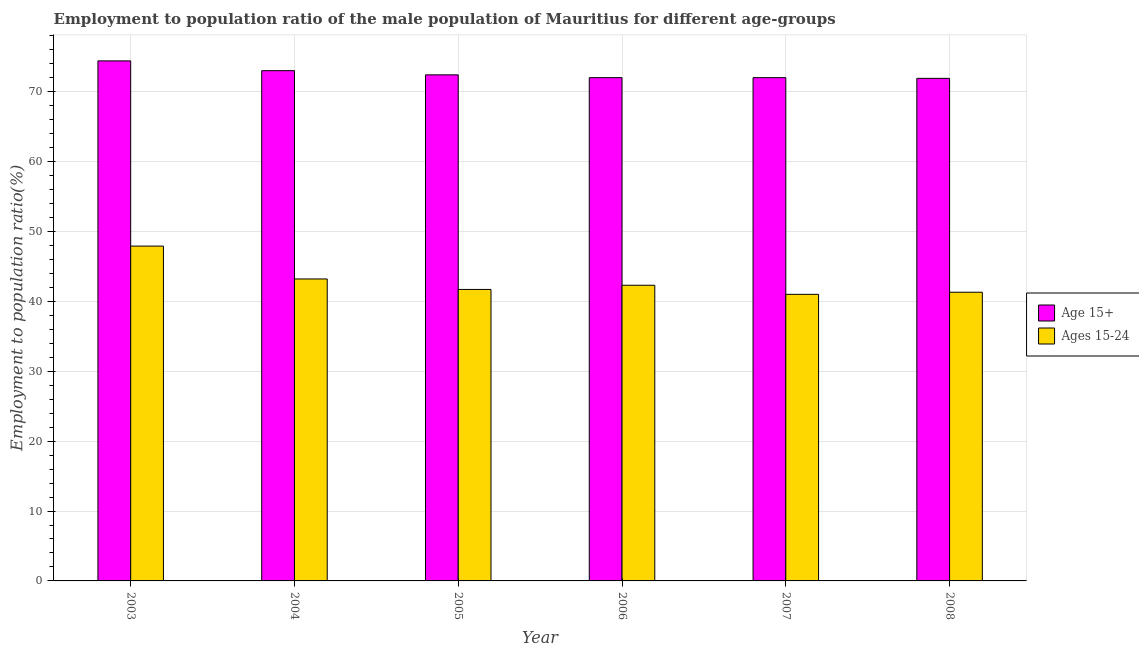How many groups of bars are there?
Ensure brevity in your answer.  6. Are the number of bars on each tick of the X-axis equal?
Give a very brief answer. Yes. How many bars are there on the 6th tick from the right?
Offer a terse response. 2. What is the employment to population ratio(age 15-24) in 2007?
Ensure brevity in your answer.  41. Across all years, what is the maximum employment to population ratio(age 15-24)?
Your response must be concise. 47.9. Across all years, what is the minimum employment to population ratio(age 15-24)?
Your answer should be compact. 41. What is the total employment to population ratio(age 15-24) in the graph?
Ensure brevity in your answer.  257.4. What is the difference between the employment to population ratio(age 15+) in 2007 and that in 2008?
Make the answer very short. 0.1. What is the difference between the employment to population ratio(age 15+) in 2005 and the employment to population ratio(age 15-24) in 2007?
Offer a terse response. 0.4. What is the average employment to population ratio(age 15-24) per year?
Offer a terse response. 42.9. In the year 2006, what is the difference between the employment to population ratio(age 15+) and employment to population ratio(age 15-24)?
Offer a terse response. 0. What is the ratio of the employment to population ratio(age 15+) in 2006 to that in 2008?
Give a very brief answer. 1. Is the difference between the employment to population ratio(age 15-24) in 2003 and 2005 greater than the difference between the employment to population ratio(age 15+) in 2003 and 2005?
Your answer should be compact. No. What is the difference between the highest and the second highest employment to population ratio(age 15+)?
Offer a very short reply. 1.4. What is the difference between the highest and the lowest employment to population ratio(age 15-24)?
Keep it short and to the point. 6.9. Is the sum of the employment to population ratio(age 15-24) in 2005 and 2007 greater than the maximum employment to population ratio(age 15+) across all years?
Make the answer very short. Yes. What does the 1st bar from the left in 2005 represents?
Your response must be concise. Age 15+. What does the 2nd bar from the right in 2004 represents?
Your response must be concise. Age 15+. How many bars are there?
Offer a terse response. 12. Are all the bars in the graph horizontal?
Provide a short and direct response. No. What is the difference between two consecutive major ticks on the Y-axis?
Your answer should be compact. 10. Are the values on the major ticks of Y-axis written in scientific E-notation?
Your response must be concise. No. Does the graph contain any zero values?
Keep it short and to the point. No. How many legend labels are there?
Provide a short and direct response. 2. How are the legend labels stacked?
Offer a very short reply. Vertical. What is the title of the graph?
Your response must be concise. Employment to population ratio of the male population of Mauritius for different age-groups. Does "Non-pregnant women" appear as one of the legend labels in the graph?
Keep it short and to the point. No. What is the label or title of the Y-axis?
Give a very brief answer. Employment to population ratio(%). What is the Employment to population ratio(%) in Age 15+ in 2003?
Offer a terse response. 74.4. What is the Employment to population ratio(%) of Ages 15-24 in 2003?
Offer a very short reply. 47.9. What is the Employment to population ratio(%) of Age 15+ in 2004?
Provide a succinct answer. 73. What is the Employment to population ratio(%) in Ages 15-24 in 2004?
Make the answer very short. 43.2. What is the Employment to population ratio(%) in Age 15+ in 2005?
Offer a very short reply. 72.4. What is the Employment to population ratio(%) in Ages 15-24 in 2005?
Provide a short and direct response. 41.7. What is the Employment to population ratio(%) of Age 15+ in 2006?
Your answer should be very brief. 72. What is the Employment to population ratio(%) in Ages 15-24 in 2006?
Provide a succinct answer. 42.3. What is the Employment to population ratio(%) in Ages 15-24 in 2007?
Provide a succinct answer. 41. What is the Employment to population ratio(%) in Age 15+ in 2008?
Your answer should be very brief. 71.9. What is the Employment to population ratio(%) in Ages 15-24 in 2008?
Ensure brevity in your answer.  41.3. Across all years, what is the maximum Employment to population ratio(%) in Age 15+?
Your answer should be very brief. 74.4. Across all years, what is the maximum Employment to population ratio(%) in Ages 15-24?
Ensure brevity in your answer.  47.9. Across all years, what is the minimum Employment to population ratio(%) of Age 15+?
Keep it short and to the point. 71.9. Across all years, what is the minimum Employment to population ratio(%) of Ages 15-24?
Ensure brevity in your answer.  41. What is the total Employment to population ratio(%) of Age 15+ in the graph?
Provide a succinct answer. 435.7. What is the total Employment to population ratio(%) in Ages 15-24 in the graph?
Offer a very short reply. 257.4. What is the difference between the Employment to population ratio(%) of Ages 15-24 in 2003 and that in 2004?
Give a very brief answer. 4.7. What is the difference between the Employment to population ratio(%) in Ages 15-24 in 2003 and that in 2005?
Offer a terse response. 6.2. What is the difference between the Employment to population ratio(%) in Age 15+ in 2003 and that in 2006?
Keep it short and to the point. 2.4. What is the difference between the Employment to population ratio(%) of Ages 15-24 in 2003 and that in 2006?
Provide a succinct answer. 5.6. What is the difference between the Employment to population ratio(%) of Ages 15-24 in 2003 and that in 2007?
Provide a short and direct response. 6.9. What is the difference between the Employment to population ratio(%) in Age 15+ in 2003 and that in 2008?
Give a very brief answer. 2.5. What is the difference between the Employment to population ratio(%) in Ages 15-24 in 2003 and that in 2008?
Provide a short and direct response. 6.6. What is the difference between the Employment to population ratio(%) in Age 15+ in 2004 and that in 2005?
Offer a very short reply. 0.6. What is the difference between the Employment to population ratio(%) of Ages 15-24 in 2004 and that in 2005?
Provide a short and direct response. 1.5. What is the difference between the Employment to population ratio(%) of Age 15+ in 2004 and that in 2007?
Keep it short and to the point. 1. What is the difference between the Employment to population ratio(%) in Age 15+ in 2004 and that in 2008?
Your answer should be compact. 1.1. What is the difference between the Employment to population ratio(%) in Ages 15-24 in 2004 and that in 2008?
Your answer should be very brief. 1.9. What is the difference between the Employment to population ratio(%) of Age 15+ in 2005 and that in 2008?
Offer a terse response. 0.5. What is the difference between the Employment to population ratio(%) in Ages 15-24 in 2005 and that in 2008?
Make the answer very short. 0.4. What is the difference between the Employment to population ratio(%) in Ages 15-24 in 2006 and that in 2007?
Give a very brief answer. 1.3. What is the difference between the Employment to population ratio(%) of Ages 15-24 in 2006 and that in 2008?
Provide a succinct answer. 1. What is the difference between the Employment to population ratio(%) in Ages 15-24 in 2007 and that in 2008?
Your answer should be very brief. -0.3. What is the difference between the Employment to population ratio(%) in Age 15+ in 2003 and the Employment to population ratio(%) in Ages 15-24 in 2004?
Keep it short and to the point. 31.2. What is the difference between the Employment to population ratio(%) in Age 15+ in 2003 and the Employment to population ratio(%) in Ages 15-24 in 2005?
Offer a very short reply. 32.7. What is the difference between the Employment to population ratio(%) of Age 15+ in 2003 and the Employment to population ratio(%) of Ages 15-24 in 2006?
Your response must be concise. 32.1. What is the difference between the Employment to population ratio(%) in Age 15+ in 2003 and the Employment to population ratio(%) in Ages 15-24 in 2007?
Offer a very short reply. 33.4. What is the difference between the Employment to population ratio(%) of Age 15+ in 2003 and the Employment to population ratio(%) of Ages 15-24 in 2008?
Give a very brief answer. 33.1. What is the difference between the Employment to population ratio(%) of Age 15+ in 2004 and the Employment to population ratio(%) of Ages 15-24 in 2005?
Your answer should be very brief. 31.3. What is the difference between the Employment to population ratio(%) in Age 15+ in 2004 and the Employment to population ratio(%) in Ages 15-24 in 2006?
Your answer should be very brief. 30.7. What is the difference between the Employment to population ratio(%) of Age 15+ in 2004 and the Employment to population ratio(%) of Ages 15-24 in 2007?
Keep it short and to the point. 32. What is the difference between the Employment to population ratio(%) in Age 15+ in 2004 and the Employment to population ratio(%) in Ages 15-24 in 2008?
Give a very brief answer. 31.7. What is the difference between the Employment to population ratio(%) in Age 15+ in 2005 and the Employment to population ratio(%) in Ages 15-24 in 2006?
Offer a very short reply. 30.1. What is the difference between the Employment to population ratio(%) of Age 15+ in 2005 and the Employment to population ratio(%) of Ages 15-24 in 2007?
Your response must be concise. 31.4. What is the difference between the Employment to population ratio(%) of Age 15+ in 2005 and the Employment to population ratio(%) of Ages 15-24 in 2008?
Provide a succinct answer. 31.1. What is the difference between the Employment to population ratio(%) in Age 15+ in 2006 and the Employment to population ratio(%) in Ages 15-24 in 2008?
Ensure brevity in your answer.  30.7. What is the difference between the Employment to population ratio(%) of Age 15+ in 2007 and the Employment to population ratio(%) of Ages 15-24 in 2008?
Your answer should be very brief. 30.7. What is the average Employment to population ratio(%) in Age 15+ per year?
Offer a terse response. 72.62. What is the average Employment to population ratio(%) in Ages 15-24 per year?
Provide a succinct answer. 42.9. In the year 2003, what is the difference between the Employment to population ratio(%) of Age 15+ and Employment to population ratio(%) of Ages 15-24?
Offer a terse response. 26.5. In the year 2004, what is the difference between the Employment to population ratio(%) of Age 15+ and Employment to population ratio(%) of Ages 15-24?
Offer a terse response. 29.8. In the year 2005, what is the difference between the Employment to population ratio(%) of Age 15+ and Employment to population ratio(%) of Ages 15-24?
Your answer should be very brief. 30.7. In the year 2006, what is the difference between the Employment to population ratio(%) of Age 15+ and Employment to population ratio(%) of Ages 15-24?
Your response must be concise. 29.7. In the year 2007, what is the difference between the Employment to population ratio(%) of Age 15+ and Employment to population ratio(%) of Ages 15-24?
Your response must be concise. 31. In the year 2008, what is the difference between the Employment to population ratio(%) of Age 15+ and Employment to population ratio(%) of Ages 15-24?
Provide a succinct answer. 30.6. What is the ratio of the Employment to population ratio(%) of Age 15+ in 2003 to that in 2004?
Ensure brevity in your answer.  1.02. What is the ratio of the Employment to population ratio(%) of Ages 15-24 in 2003 to that in 2004?
Give a very brief answer. 1.11. What is the ratio of the Employment to population ratio(%) in Age 15+ in 2003 to that in 2005?
Offer a very short reply. 1.03. What is the ratio of the Employment to population ratio(%) in Ages 15-24 in 2003 to that in 2005?
Offer a terse response. 1.15. What is the ratio of the Employment to population ratio(%) in Ages 15-24 in 2003 to that in 2006?
Make the answer very short. 1.13. What is the ratio of the Employment to population ratio(%) of Ages 15-24 in 2003 to that in 2007?
Offer a terse response. 1.17. What is the ratio of the Employment to population ratio(%) of Age 15+ in 2003 to that in 2008?
Make the answer very short. 1.03. What is the ratio of the Employment to population ratio(%) of Ages 15-24 in 2003 to that in 2008?
Ensure brevity in your answer.  1.16. What is the ratio of the Employment to population ratio(%) of Age 15+ in 2004 to that in 2005?
Offer a terse response. 1.01. What is the ratio of the Employment to population ratio(%) of Ages 15-24 in 2004 to that in 2005?
Offer a very short reply. 1.04. What is the ratio of the Employment to population ratio(%) of Age 15+ in 2004 to that in 2006?
Offer a very short reply. 1.01. What is the ratio of the Employment to population ratio(%) in Ages 15-24 in 2004 to that in 2006?
Your answer should be compact. 1.02. What is the ratio of the Employment to population ratio(%) in Age 15+ in 2004 to that in 2007?
Your answer should be compact. 1.01. What is the ratio of the Employment to population ratio(%) in Ages 15-24 in 2004 to that in 2007?
Your answer should be compact. 1.05. What is the ratio of the Employment to population ratio(%) in Age 15+ in 2004 to that in 2008?
Your answer should be compact. 1.02. What is the ratio of the Employment to population ratio(%) of Ages 15-24 in 2004 to that in 2008?
Keep it short and to the point. 1.05. What is the ratio of the Employment to population ratio(%) of Age 15+ in 2005 to that in 2006?
Your answer should be very brief. 1.01. What is the ratio of the Employment to population ratio(%) of Ages 15-24 in 2005 to that in 2006?
Your response must be concise. 0.99. What is the ratio of the Employment to population ratio(%) of Age 15+ in 2005 to that in 2007?
Your answer should be very brief. 1.01. What is the ratio of the Employment to population ratio(%) of Ages 15-24 in 2005 to that in 2007?
Your answer should be very brief. 1.02. What is the ratio of the Employment to population ratio(%) in Age 15+ in 2005 to that in 2008?
Your answer should be compact. 1.01. What is the ratio of the Employment to population ratio(%) of Ages 15-24 in 2005 to that in 2008?
Give a very brief answer. 1.01. What is the ratio of the Employment to population ratio(%) in Ages 15-24 in 2006 to that in 2007?
Offer a terse response. 1.03. What is the ratio of the Employment to population ratio(%) in Age 15+ in 2006 to that in 2008?
Keep it short and to the point. 1. What is the ratio of the Employment to population ratio(%) of Ages 15-24 in 2006 to that in 2008?
Your response must be concise. 1.02. What is the difference between the highest and the second highest Employment to population ratio(%) of Age 15+?
Offer a terse response. 1.4. What is the difference between the highest and the lowest Employment to population ratio(%) of Age 15+?
Provide a short and direct response. 2.5. 